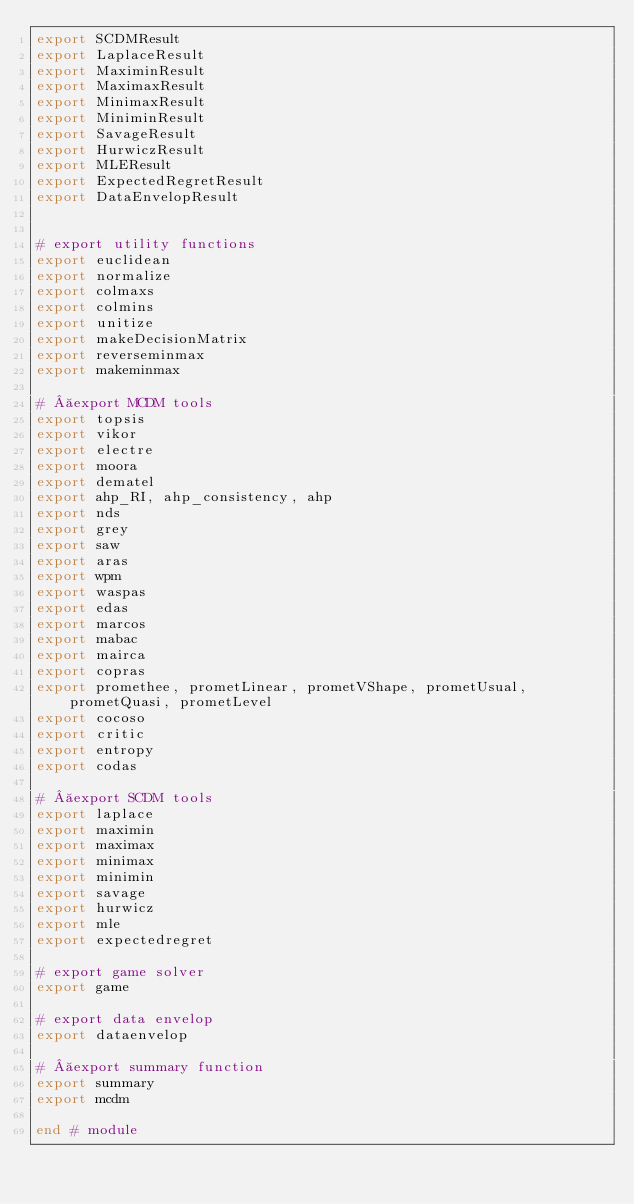<code> <loc_0><loc_0><loc_500><loc_500><_Julia_>export SCDMResult
export LaplaceResult
export MaximinResult
export MaximaxResult
export MinimaxResult
export MiniminResult
export SavageResult
export HurwiczResult
export MLEResult
export ExpectedRegretResult
export DataEnvelopResult


# export utility functions
export euclidean
export normalize
export colmaxs
export colmins
export unitize
export makeDecisionMatrix
export reverseminmax
export makeminmax

#  export MCDM tools
export topsis
export vikor
export electre
export moora
export dematel
export ahp_RI, ahp_consistency, ahp
export nds
export grey
export saw
export aras
export wpm
export waspas
export edas
export marcos
export mabac
export mairca
export copras
export promethee, prometLinear, prometVShape, prometUsual, prometQuasi, prometLevel
export cocoso
export critic
export entropy
export codas

#  export SCDM tools
export laplace
export maximin
export maximax
export minimax
export minimin
export savage
export hurwicz
export mle
export expectedregret

# export game solver
export game

# export data envelop
export dataenvelop

#  export summary function
export summary
export mcdm

end # module
</code> 